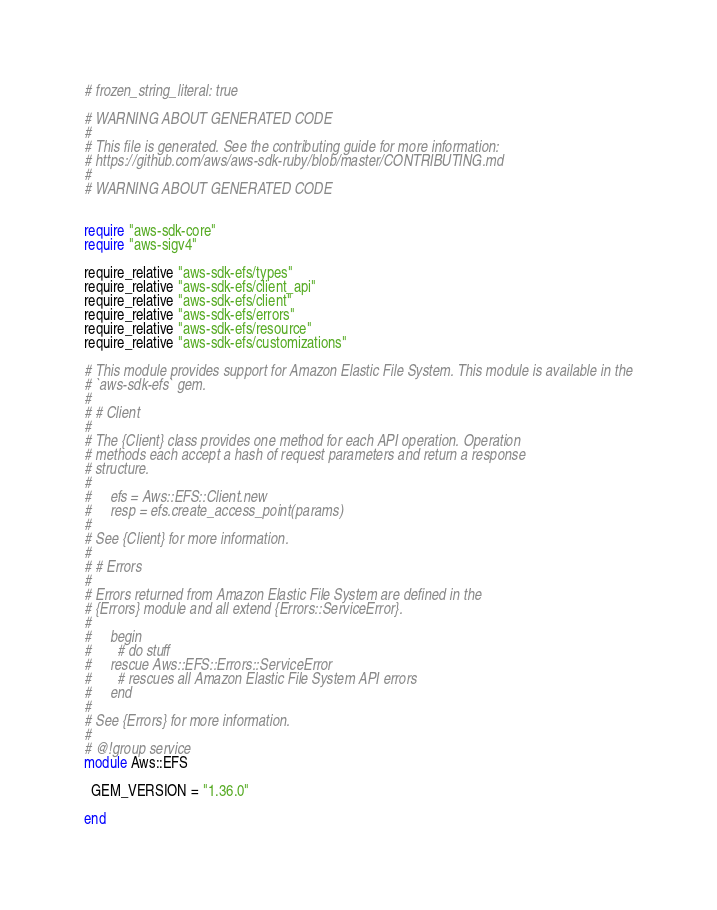Convert code to text. <code><loc_0><loc_0><loc_500><loc_500><_Crystal_># frozen_string_literal: true

# WARNING ABOUT GENERATED CODE
#
# This file is generated. See the contributing guide for more information:
# https://github.com/aws/aws-sdk-ruby/blob/master/CONTRIBUTING.md
#
# WARNING ABOUT GENERATED CODE


require "aws-sdk-core"
require "aws-sigv4"

require_relative "aws-sdk-efs/types"
require_relative "aws-sdk-efs/client_api"
require_relative "aws-sdk-efs/client"
require_relative "aws-sdk-efs/errors"
require_relative "aws-sdk-efs/resource"
require_relative "aws-sdk-efs/customizations"

# This module provides support for Amazon Elastic File System. This module is available in the
# `aws-sdk-efs` gem.
#
# # Client
#
# The {Client} class provides one method for each API operation. Operation
# methods each accept a hash of request parameters and return a response
# structure.
#
#     efs = Aws::EFS::Client.new
#     resp = efs.create_access_point(params)
#
# See {Client} for more information.
#
# # Errors
#
# Errors returned from Amazon Elastic File System are defined in the
# {Errors} module and all extend {Errors::ServiceError}.
#
#     begin
#       # do stuff
#     rescue Aws::EFS::Errors::ServiceError
#       # rescues all Amazon Elastic File System API errors
#     end
#
# See {Errors} for more information.
#
# @!group service
module Aws::EFS

  GEM_VERSION = "1.36.0"

end
</code> 